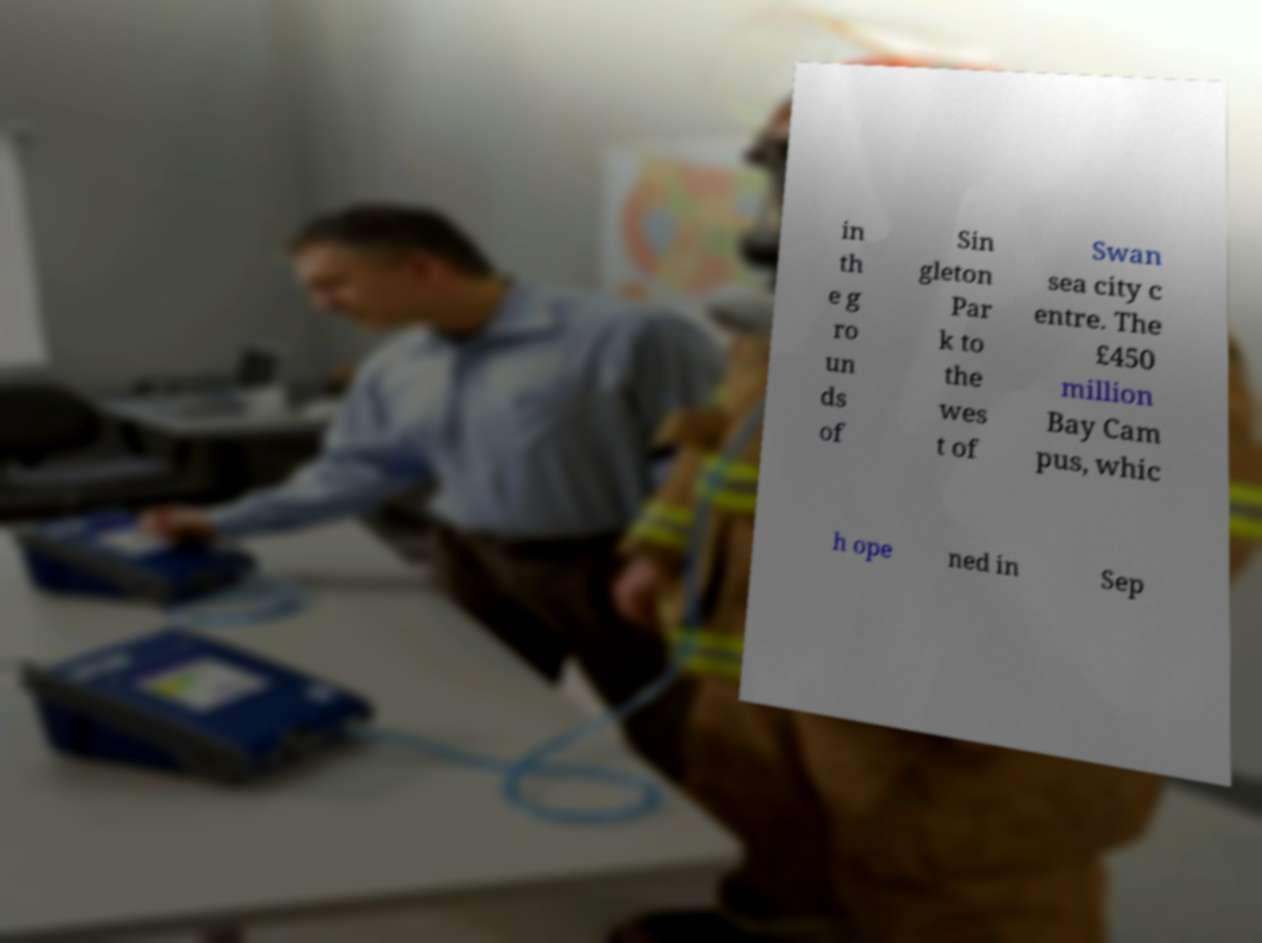Can you accurately transcribe the text from the provided image for me? in th e g ro un ds of Sin gleton Par k to the wes t of Swan sea city c entre. The £450 million Bay Cam pus, whic h ope ned in Sep 